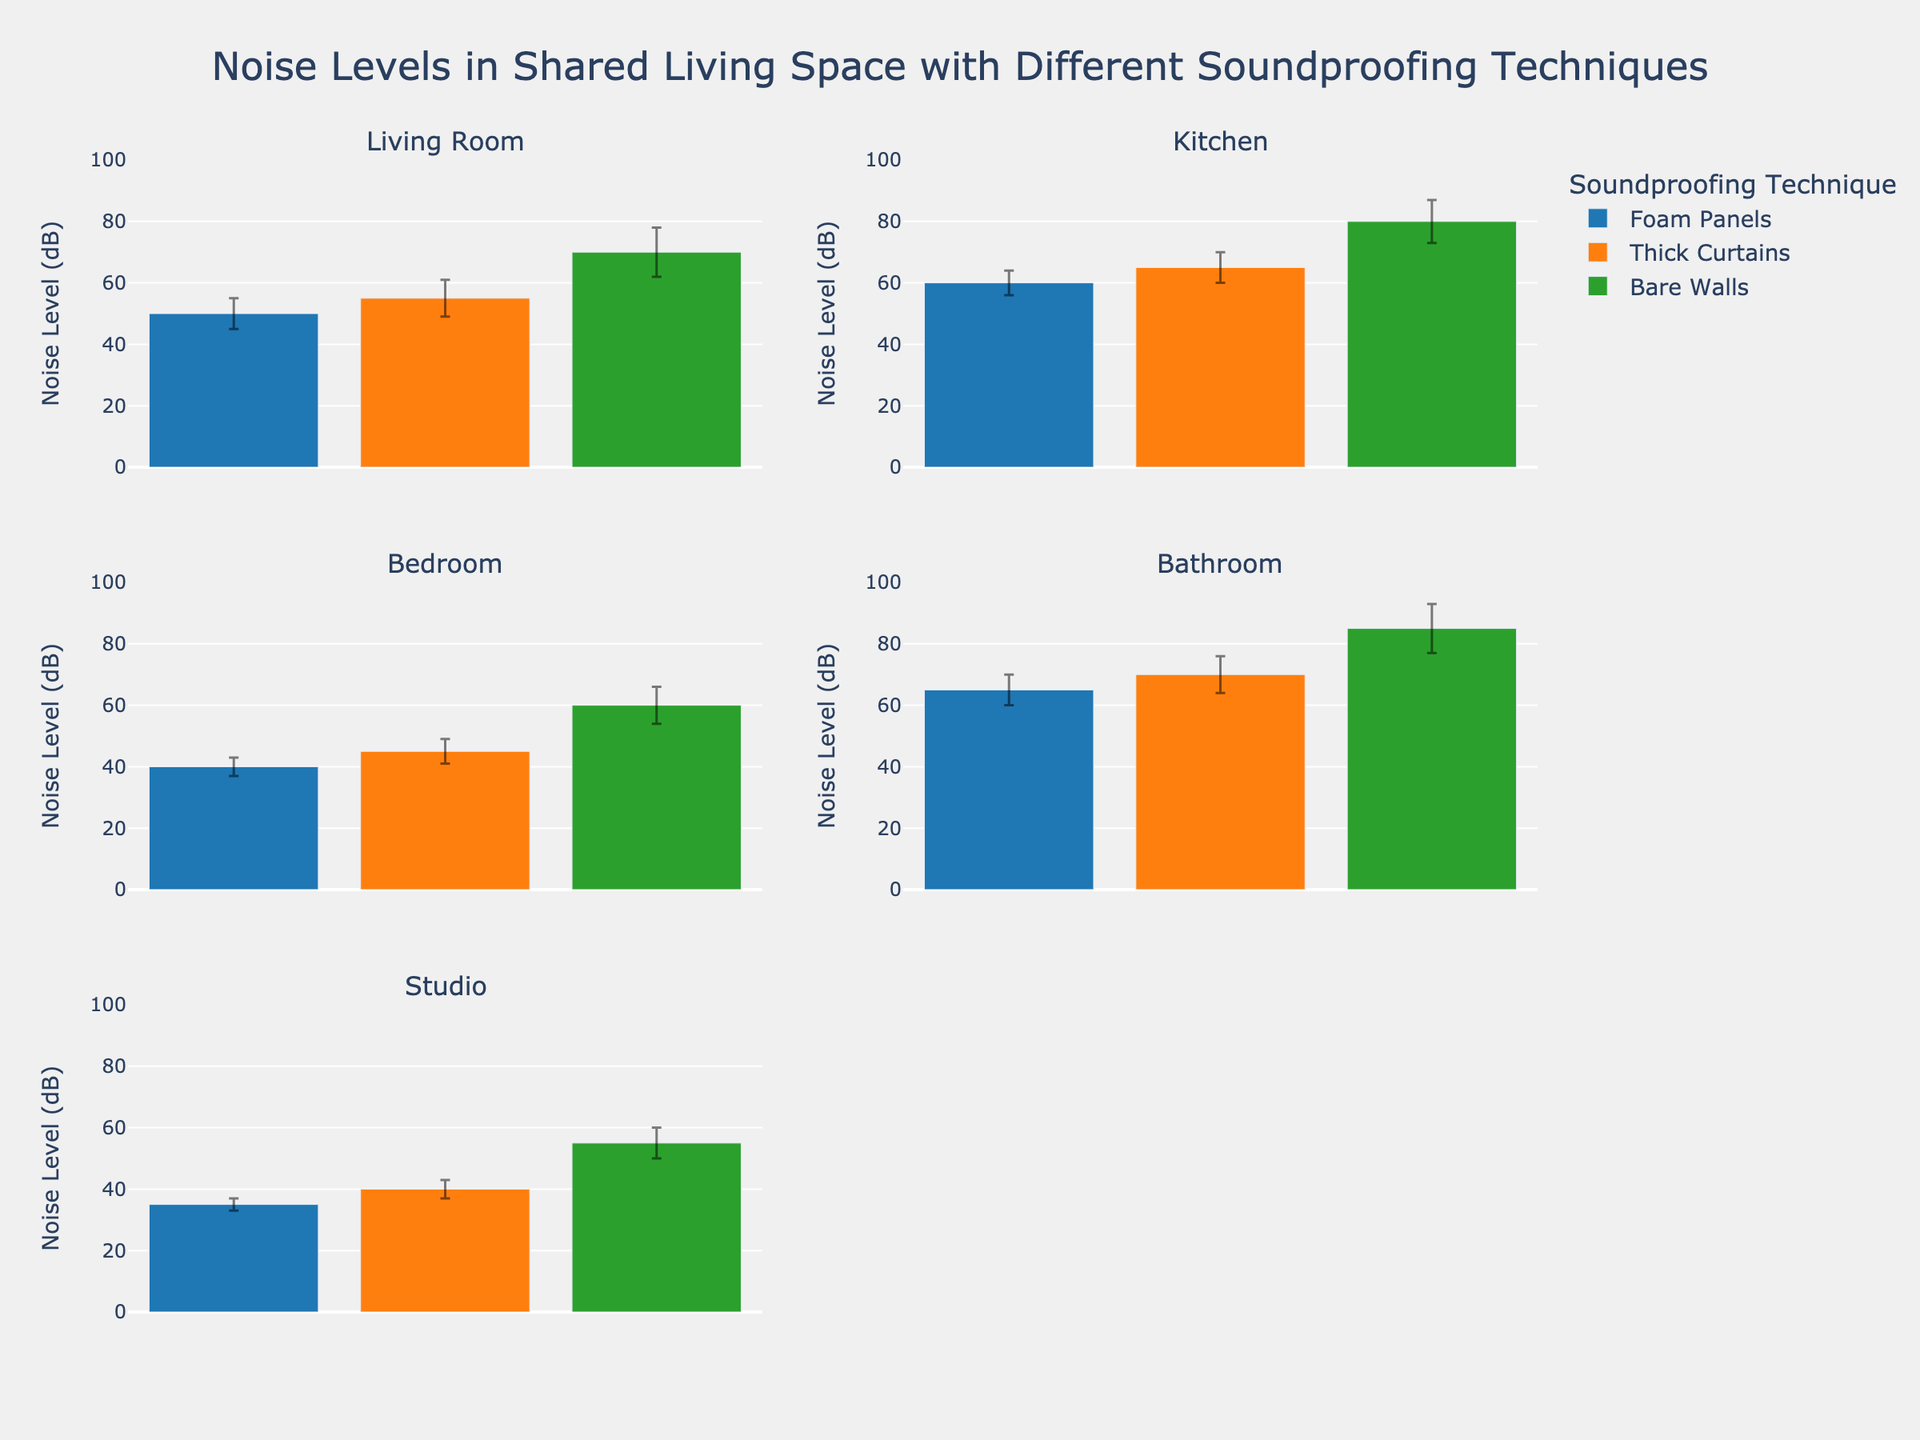What is the title of the figure? The title is located at the top center of the figure and reads "Noise Levels in Shared Living Space with Different Soundproofing Techniques".
Answer: Noise Levels in Shared Living Space with Different Soundproofing Techniques What are the noise levels in the Living Room for each soundproofing technique? The Living Room subplot shows three bars representing Foam Panels, Thick Curtains, and Bare Walls. The noise levels for these techniques are 50 dB, 55 dB, and 70 dB respectively.
Answer: 50 dB, 55 dB, 70 dB Which room has the lowest average noise level with Foam Panels? By examining the Foam Panels bars across all subplots, the Studio shows the lowest noise level of 35 dB.
Answer: Studio How much higher is the noise level in the Bathroom with Bare Walls compared to Foam Panels? The noise level in the Bathroom with Bare Walls is 85 dB, and with Foam Panels, it is 65 dB. The difference is 85 - 65 = 20 dB.
Answer: 20 dB Which soundproofing technique shows the most consistent noise reduction across all rooms? Consistency can be inferred by examining the error bars. Foam Panels generally have smaller error bars across all rooms, indicating consistent noise reduction.
Answer: Foam Panels How does the noise level in the Kitchen with Thick Curtains compare to the Bedroom with Bare Walls? The noise level in the Kitchen with Thick Curtains is 65 dB, while the Bedroom with Bare Walls is 60 dB. Thus, the Kitchen with Thick Curtains is louder by 5 dB.
Answer: 5 dB Which two rooms have the highest difference in noise levels when using Bare Walls? The highest noise levels with Bare Walls are in the Bathroom (85 dB) and the Bedroom (60 dB). The difference is 85 - 60 = 25 dB.
Answer: Bathroom and Bedroom What is the average noise level for each soundproofing technique across all rooms? First, sum the average noise levels for each technique across all rooms and then divide by the number of data points: 
- Foam Panels: (50 + 60 + 40 + 65 + 35) / 5 = 50 dB 
- Thick Curtains: (55 + 65 + 45 + 70 + 40) / 5 = 55 dB 
- Bare Walls: (70 + 80 + 60 + 85 + 55) / 5 = 70 dB
Answer: 50 dB, 55 dB, 70 dB Which room sees the greatest noise level improvement when switching from Bare Walls to Foam Panels? By looking at the difference between Bare Walls and Foam Panels noise levels:
- Living Room: 70 - 50 = 20 dB
- Kitchen: 80 - 60 = 20 dB
- Bedroom: 60 - 40 = 20 dB
- Bathroom: 85 - 65 = 20 dB
- Studio: 55 - 35 = 20 dB
Since all rooms show the same 20 dB improvement, none is greater than the others.
Answer: All rooms show equal improvement What is the standard deviation of noise levels in the Living Room with Thick Curtains? In the Living Room subplot, the bar for Thick Curtains has an error bar indicating the standard deviation, which is 6 dB.
Answer: 6 dB 